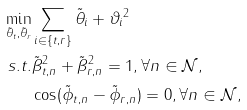<formula> <loc_0><loc_0><loc_500><loc_500>\min _ { \tilde { \theta } _ { t } , \tilde { \theta } _ { r } } & \sum _ { i \in \{ t , r \} } \| \tilde { \theta } _ { i } + \vartheta _ { i } \| ^ { 2 } \\ s . t . & \tilde { \beta } _ { t , n } ^ { 2 } + \tilde { \beta } _ { r , n } ^ { 2 } = 1 , \forall n \in \mathcal { N } , \\ & \cos ( \tilde { \phi } _ { t , n } - \tilde { \phi } _ { r , n } ) = 0 , \forall n \in \mathcal { N } ,</formula> 